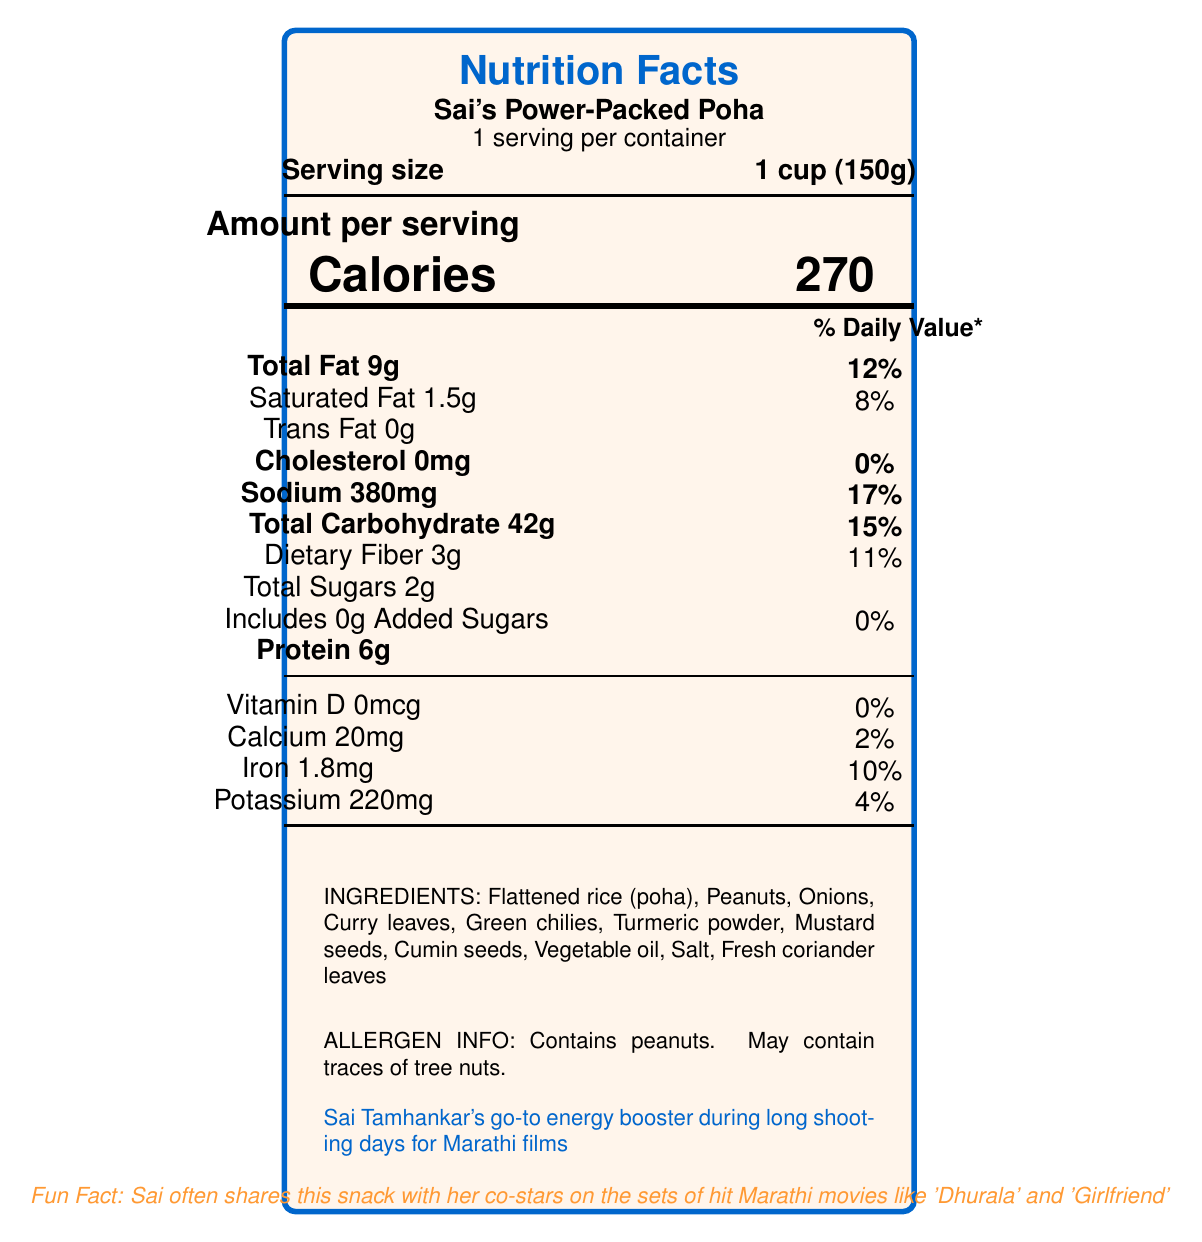What is the serving size of Sai's Power-Packed Poha? The document mentions in the section "Serving size" that it is 1 cup (150g).
Answer: 1 cup (150g) How many calories are there per serving? The number of calories per serving is shown prominently in the "Amount per serving" section.
Answer: 270 What percentage of the daily value of sodium does Sai's Power-Packed Poha provide? In the document under "Sodium," it is mentioned that it provides 17% of the daily value.
Answer: 17% How much dietary fiber is present in one serving? The document states that each serving contains 3g of dietary fiber.
Answer: 3g What are the main ingredients used in Sai's Power-Packed Poha? The ingredients are listed in the document under the "INGREDIENTS" section.
Answer: Flattened rice (poha), Peanuts, Onions, Curry leaves, Green chilies, Turmeric powder, Mustard seeds, Cumin seeds, Vegetable oil, Salt, Fresh coriander leaves Does the snack contain any cholesterol? According to the "Cholesterol" section, the amount is 0mg, indicating the snack contains no cholesterol.
Answer: No What allergens are indicated in the allergen information? The allergen information section specifies this.
Answer: Contains peanuts. May contain traces of tree nuts. Which of the following is not a component of Sai's Power-Packed Poha?
1. Mustard seeds
2. Garlic
3. Flattened rice (poha)
4. Turmeric powder The ingredient list does not mention garlic.
Answer: 2. Garlic What is the amount of protein per serving? 
i. 6g
ii. 10g
iii. 2g The document states under "Protein" that one serving contains 6g of protein.
Answer: i. 6g Is the snack high in trans fat? According to the "Trans Fat" section, it contains 0g of trans fat, indicating it is not high in trans fat.
Answer: No What detail links the snack to Marathi cinema? The document mentions this connection at the bottom in a special text box.
Answer: Sai Tamhankar's go-to energy booster during long shooting days for Marathi films Provide a summary describing the document. The document is formatted with nutritional data, ingredients, allergen info, and some personal anecdotes connecting to Marathi cinema actress Sai Tamhankar.
Answer: The document is a Nutrition Facts Label for Sai's Power-Packed Poha, listing serving size, caloric content, macronutrient information (total fat, saturated fat, etc.), vitamins and minerals, and the ingredients used. It also specifies allergen information and includes a fun fact about Sai Tamhankar's habit of sharing the snack on Marathi film sets. How many movies are listed in the fun fact section? The document mentions 'Dhurala' and 'Girlfriend.'
Answer: Two Can the document provide details about Sai Tamhankar's diet plan? The document only provides nutritional information about Sai's favorite snack; it does not provide comprehensive details about her entire diet plan.
Answer: Not enough information 